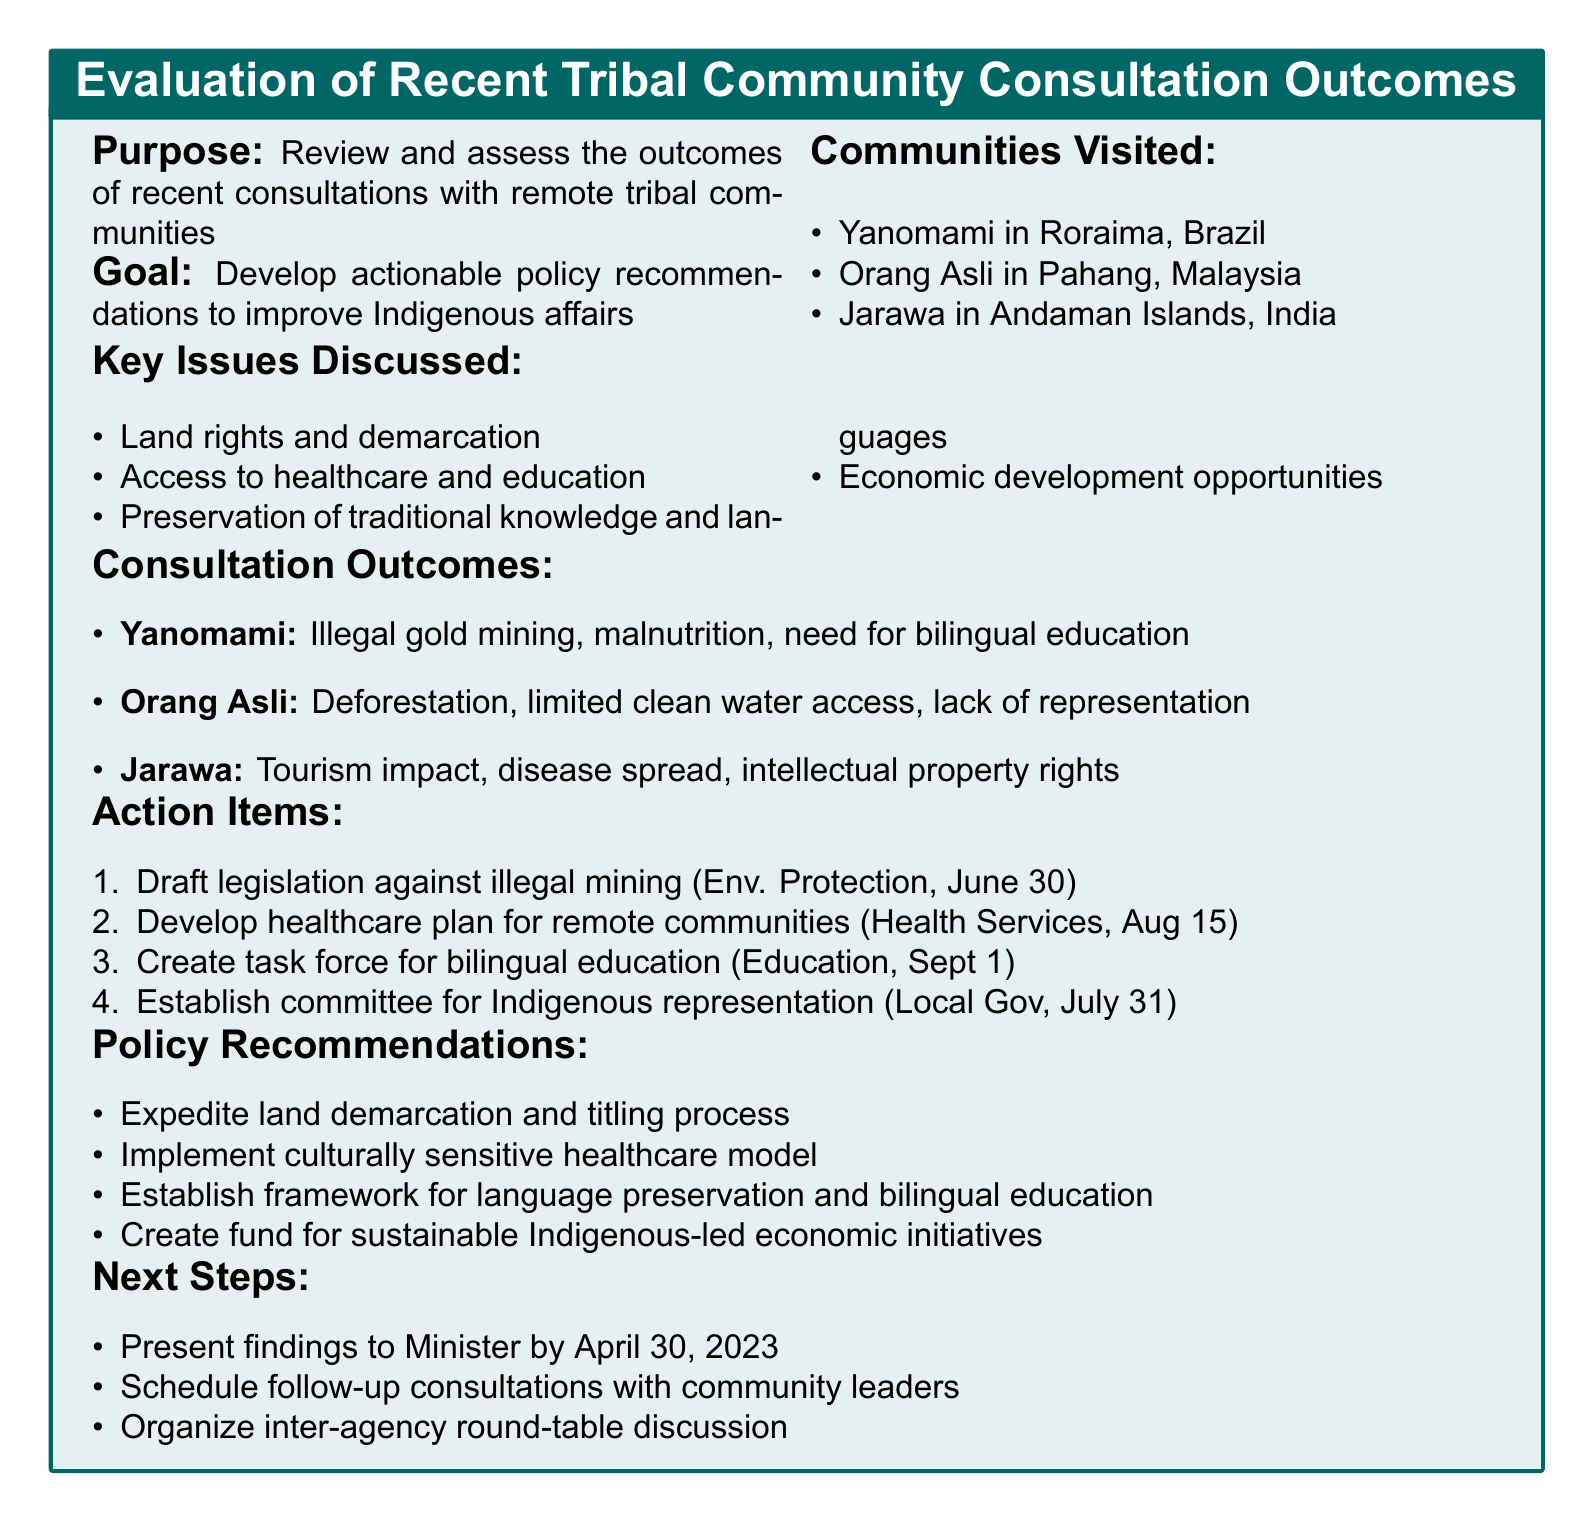What is the title of the agenda? The title of the agenda is stated at the beginning of the document.
Answer: Evaluation of Recent Tribal Community Consultation Outcomes and Action Items for Policy Recommendations Which communities were visited? The document lists the communities that were visited during the consultations.
Answer: Yanomami, Orang Asli, Jarawa What was a main concern for the Yanomami community? The main concerns for each community are listed under their respective outcomes.
Answer: Illegal gold mining encroachment What is one action item related to healthcare? The document specifies various action items, including those related to healthcare services.
Answer: Develop a comprehensive healthcare plan for remote tribal communities What is the deadline for establishing a committee for Indigenous representation? The deadline for the action item regarding Indigenous representation is specified in the document.
Answer: July 31, 2023 Which department is responsible for the legislation against illegal mining? The responsible department is included in the action items section of the document.
Answer: Department of Environmental Protection What potential impact is associated with expedited land demarcation? The document outlines the potential impact for each policy recommendation.
Answer: Increased security and autonomy for tribal communities What is the next step regarding stakeholder engagement? The next steps section outlines plans for engaging with stakeholders.
Answer: Schedule follow-up consultations with community leaders What is the timeframe for the consultations? The timeframe for the consultations is clearly mentioned in the document.
Answer: January - March 2023 